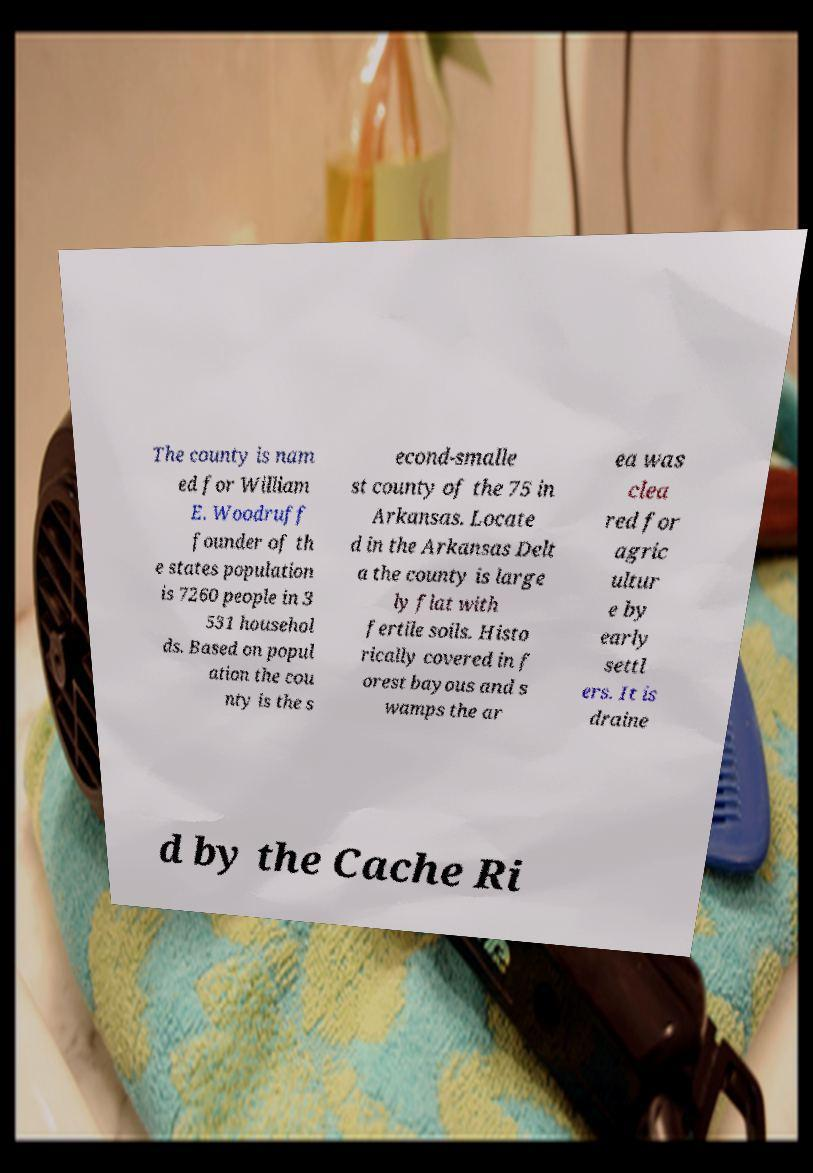Can you accurately transcribe the text from the provided image for me? The county is nam ed for William E. Woodruff founder of th e states population is 7260 people in 3 531 househol ds. Based on popul ation the cou nty is the s econd-smalle st county of the 75 in Arkansas. Locate d in the Arkansas Delt a the county is large ly flat with fertile soils. Histo rically covered in f orest bayous and s wamps the ar ea was clea red for agric ultur e by early settl ers. It is draine d by the Cache Ri 